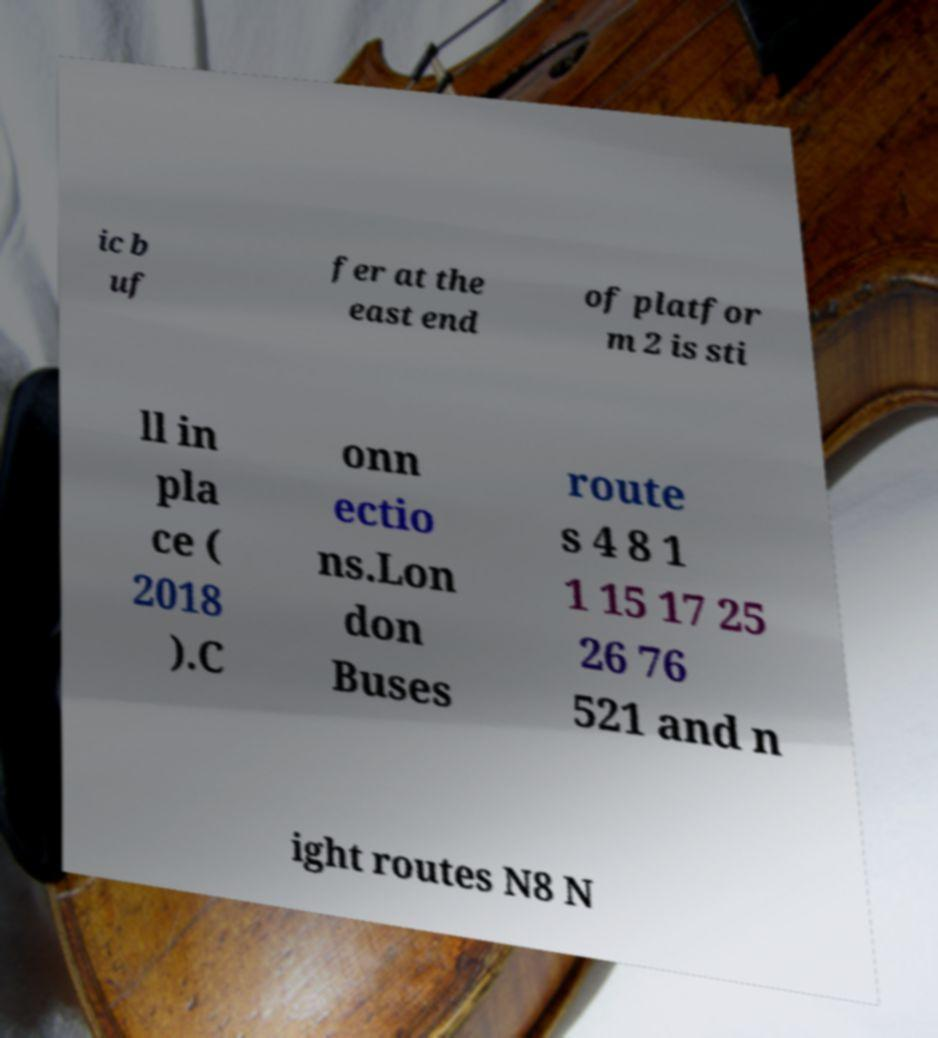For documentation purposes, I need the text within this image transcribed. Could you provide that? ic b uf fer at the east end of platfor m 2 is sti ll in pla ce ( 2018 ).C onn ectio ns.Lon don Buses route s 4 8 1 1 15 17 25 26 76 521 and n ight routes N8 N 